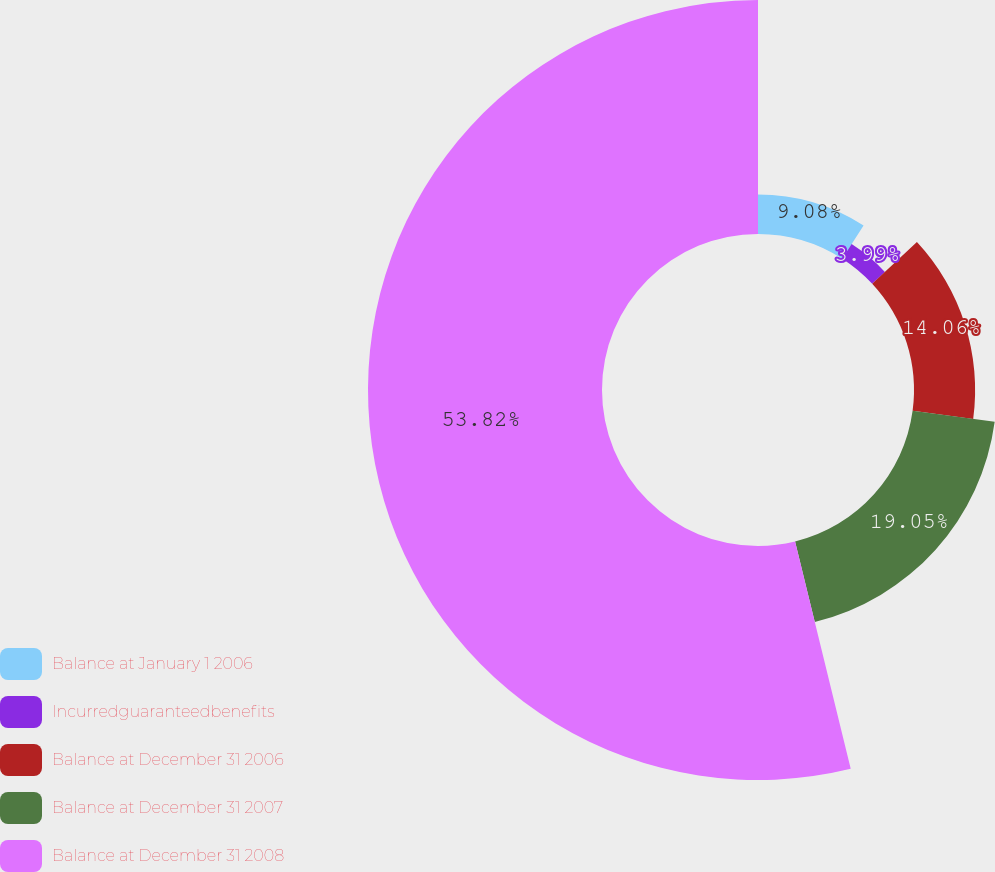<chart> <loc_0><loc_0><loc_500><loc_500><pie_chart><fcel>Balance at January 1 2006<fcel>Incurredguaranteedbenefits<fcel>Balance at December 31 2006<fcel>Balance at December 31 2007<fcel>Balance at December 31 2008<nl><fcel>9.08%<fcel>3.99%<fcel>14.06%<fcel>19.05%<fcel>53.82%<nl></chart> 